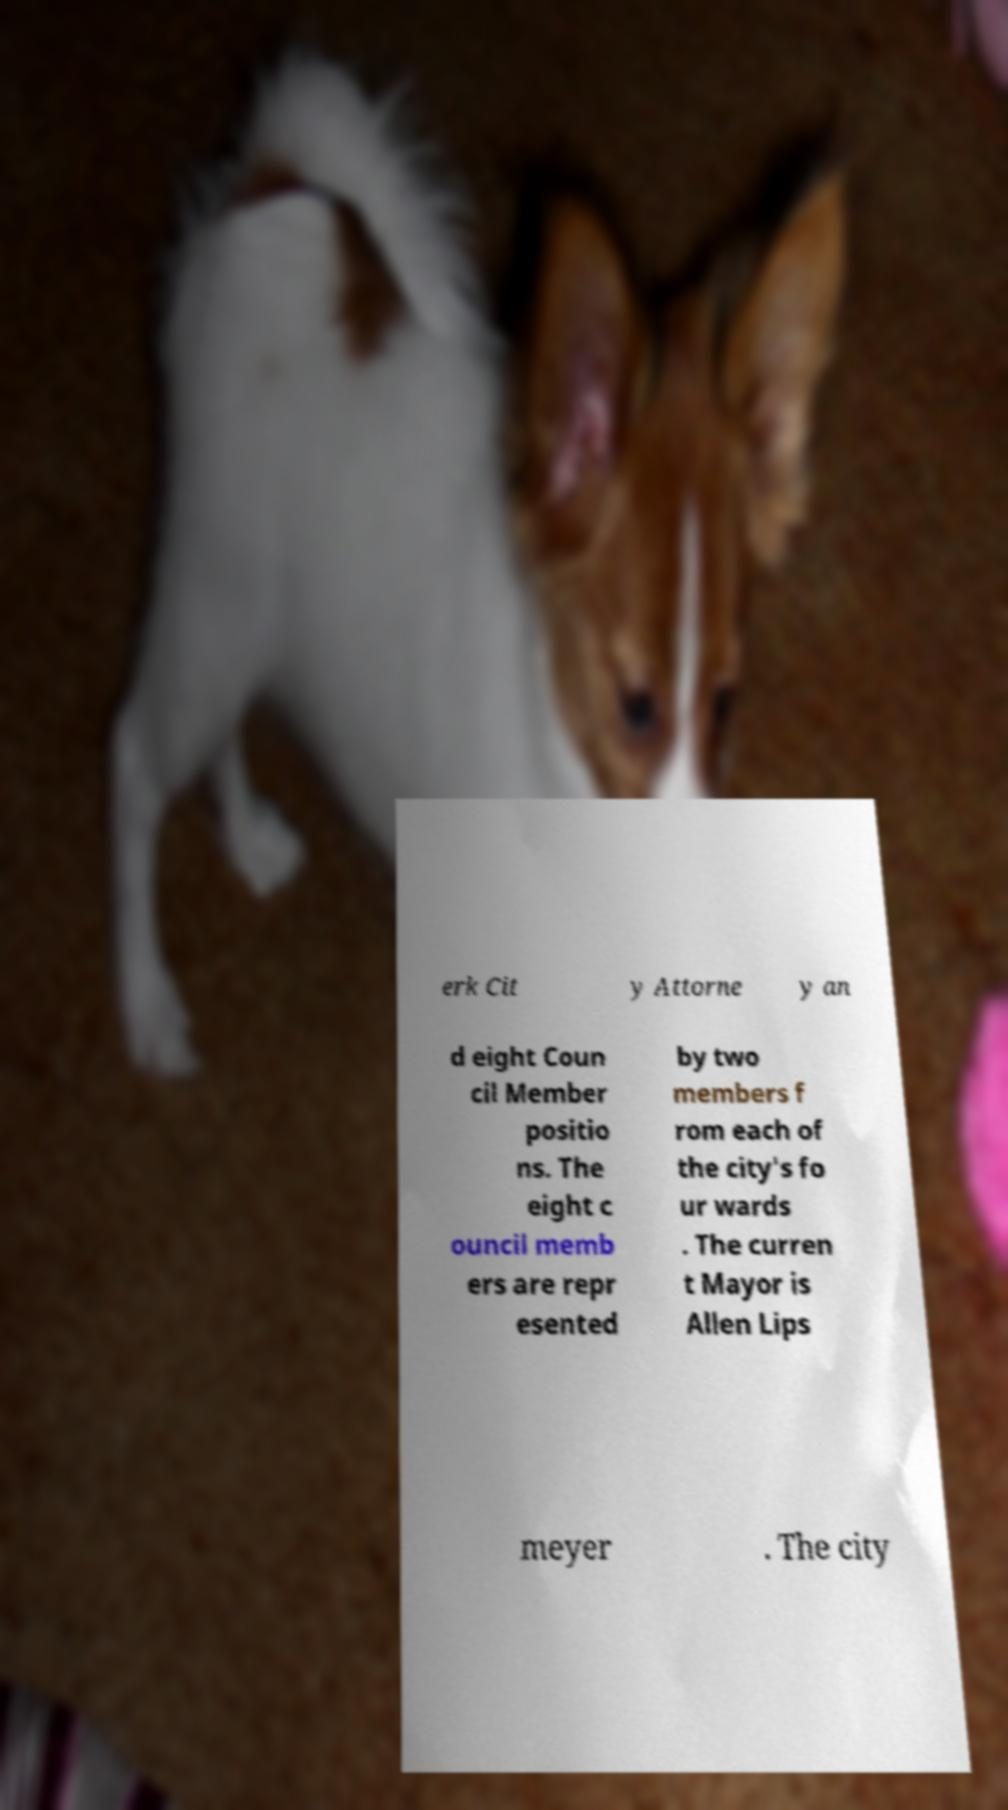There's text embedded in this image that I need extracted. Can you transcribe it verbatim? erk Cit y Attorne y an d eight Coun cil Member positio ns. The eight c ouncil memb ers are repr esented by two members f rom each of the city's fo ur wards . The curren t Mayor is Allen Lips meyer . The city 